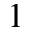Convert formula to latex. <formula><loc_0><loc_0><loc_500><loc_500>^ { 1 }</formula> 